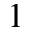Convert formula to latex. <formula><loc_0><loc_0><loc_500><loc_500>^ { 1 }</formula> 